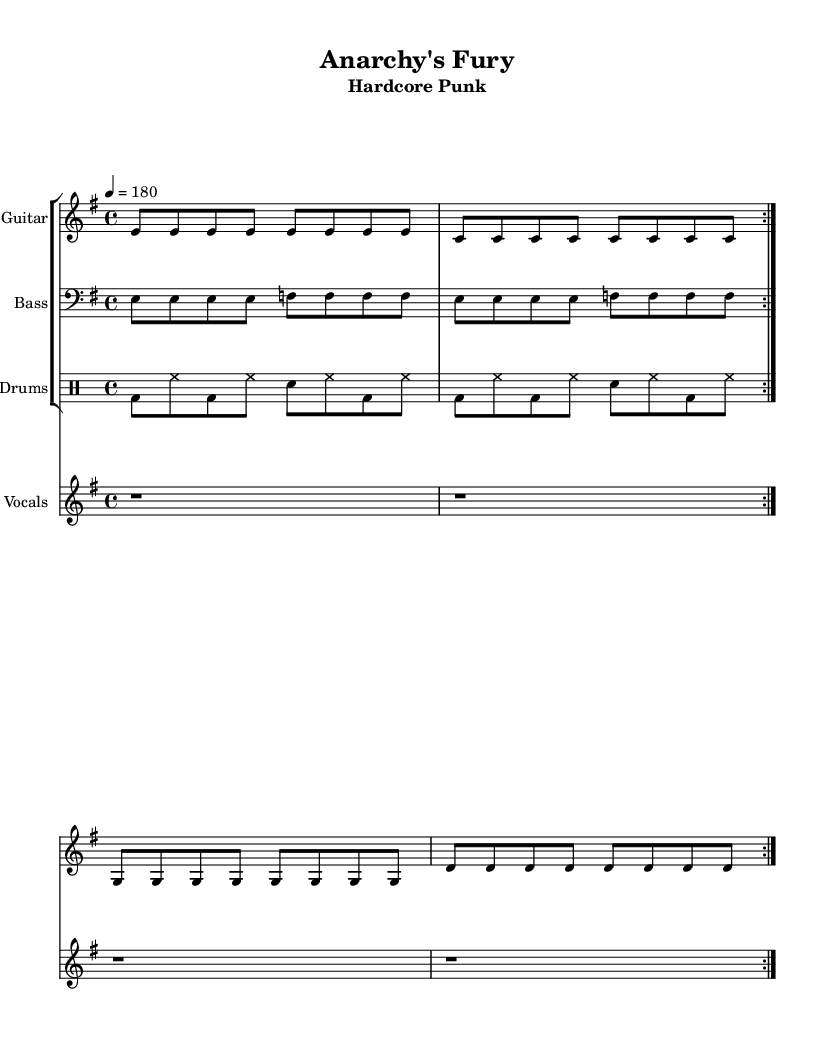What is the key signature of this music? The key signature is indicated by the sharps or flats at the beginning of the staff. In this case, there are no symbols shown, which indicates that it is E minor (the relative minor of G major).
Answer: E minor What is the time signature of the piece? The time signature is displayed at the beginning of the score and shows the number of beats per measure; here, 4/4 indicates four beats per measure with each quarter note receiving one beat.
Answer: 4/4 What is the tempo marking for this piece? The tempo is specified in beats per minute and is indicated clearly. In this sheet music, it states "4 = 180," meaning the quarter notes should be played at a speed of 180 beats per minute.
Answer: 180 How many times is the guitar riff repeated? In the guitar part, the directive "repeat volta 2" indicates to perform the riff two times. This is specifically mentioned in the music notation for the guitar.
Answer: 2 How many lines of lyrics are provided for the verse? The verse consists of four lines of lyrics, as seen when checking the lyric mode section beneath the staff for vocals, where the lines are aligned with the notes.
Answer: 4 What does "Anarchy's Fury" represent in the context of the song? The title "Anarchy's Fury" represents the central theme or message of the song, which is common in hardcore punk music. It reflects rebellion and resistance in its content, resonating with the political lyrics present throughout.
Answer: Rebellion What genre is this piece classified under? The subtitle "Hardcore Punk" indicates the genre of the piece. It also resonates with the aggressive style and themes typical of the hardcore punk music scene of the 1980s.
Answer: Hardcore Punk 